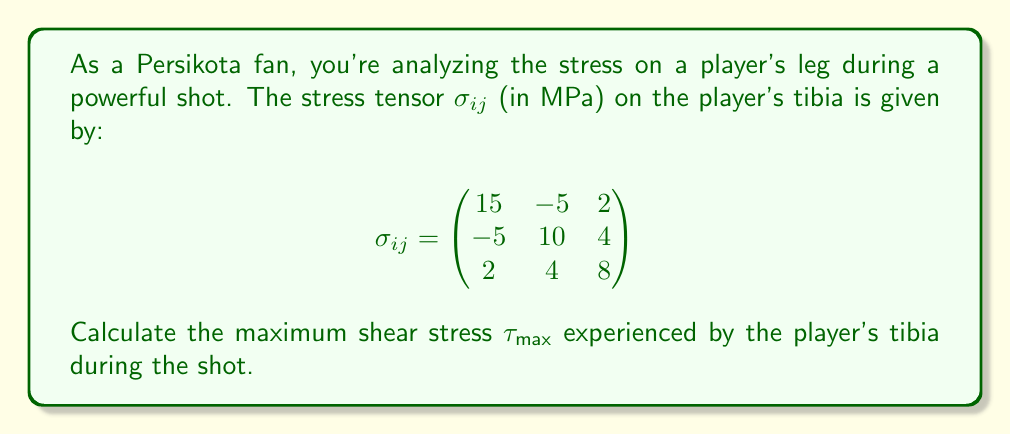Can you solve this math problem? To find the maximum shear stress, we need to follow these steps:

1) First, we need to calculate the principal stresses. The principal stresses are the eigenvalues of the stress tensor.

2) To find the eigenvalues, we solve the characteristic equation:
   $$det(\sigma_{ij} - \lambda I) = 0$$

3) Expanding this determinant:
   $$\begin{vmatrix}
   15-\lambda & -5 & 2 \\
   -5 & 10-\lambda & 4 \\
   2 & 4 & 8-\lambda
   \end{vmatrix} = 0$$

4) This yields the cubic equation:
   $$-\lambda^3 + 33\lambda^2 - 342\lambda + 1050 = 0$$

5) Solving this equation (using a calculator or computer algebra system) gives us the principal stresses:
   $$\lambda_1 \approx 18.76 \text{ MPa}$$
   $$\lambda_2 \approx 11.22 \text{ MPa}$$
   $$\lambda_3 \approx 3.02 \text{ MPa}$$

6) The maximum shear stress is given by the formula:
   $$\tau_{max} = \frac{\lambda_{max} - \lambda_{min}}{2}$$

7) Substituting the values:
   $$\tau_{max} = \frac{18.76 - 3.02}{2} = 7.87 \text{ MPa}$$
Answer: $7.87 \text{ MPa}$ 